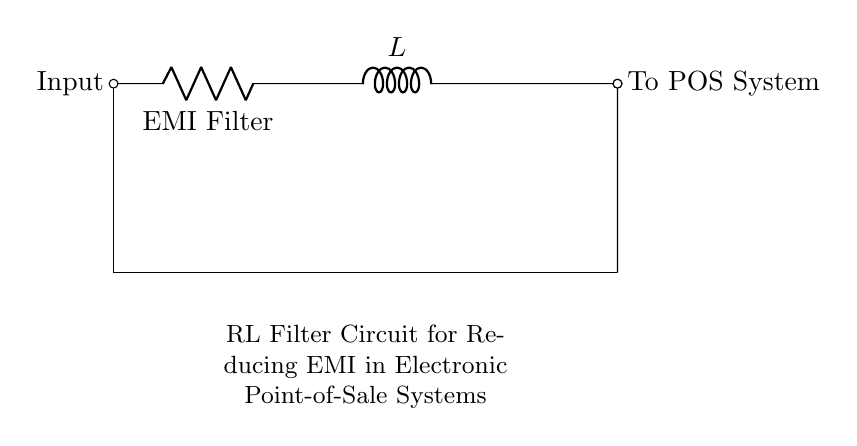What are the components used in this circuit? The circuit contains a resistor and an inductor, as indicated by the labels R and L respectively.
Answer: Resistor, Inductor What is the purpose of the resistor in the circuit? The resistor serves as an EMI filter, helping to reduce electromagnetic interference by dissipating unwanted voltage.
Answer: EMI Filter What type of circuit is represented here? The circuit is an RL filter circuit designed for signal conditioning in electronics, particularly to mitigate EMI effects.
Answer: RL filter circuit How many terminals are there for the input and output? There are two terminals for the input (one connected to the resistor) and two for the output (one connected to the end of the inductor).
Answer: Four What would happen if the inductor were removed from the circuit? Removing the inductor would eliminate its ability to oppose changes in current, weakening the EMI filtering capability of the circuit.
Answer: Reduced filtering capability How does the combination of resistor and inductor affect the impedance? The resistor contributes real part resistance while the inductor contributes reactive part inductance, resulting in a total impedance that varies with frequency.
Answer: Frequency-dependent impedance What is the connection type of the resistor and inductor in this configuration? The resistor and inductor are connected in series, allowing the current to pass through both components sequentially.
Answer: Series connection 